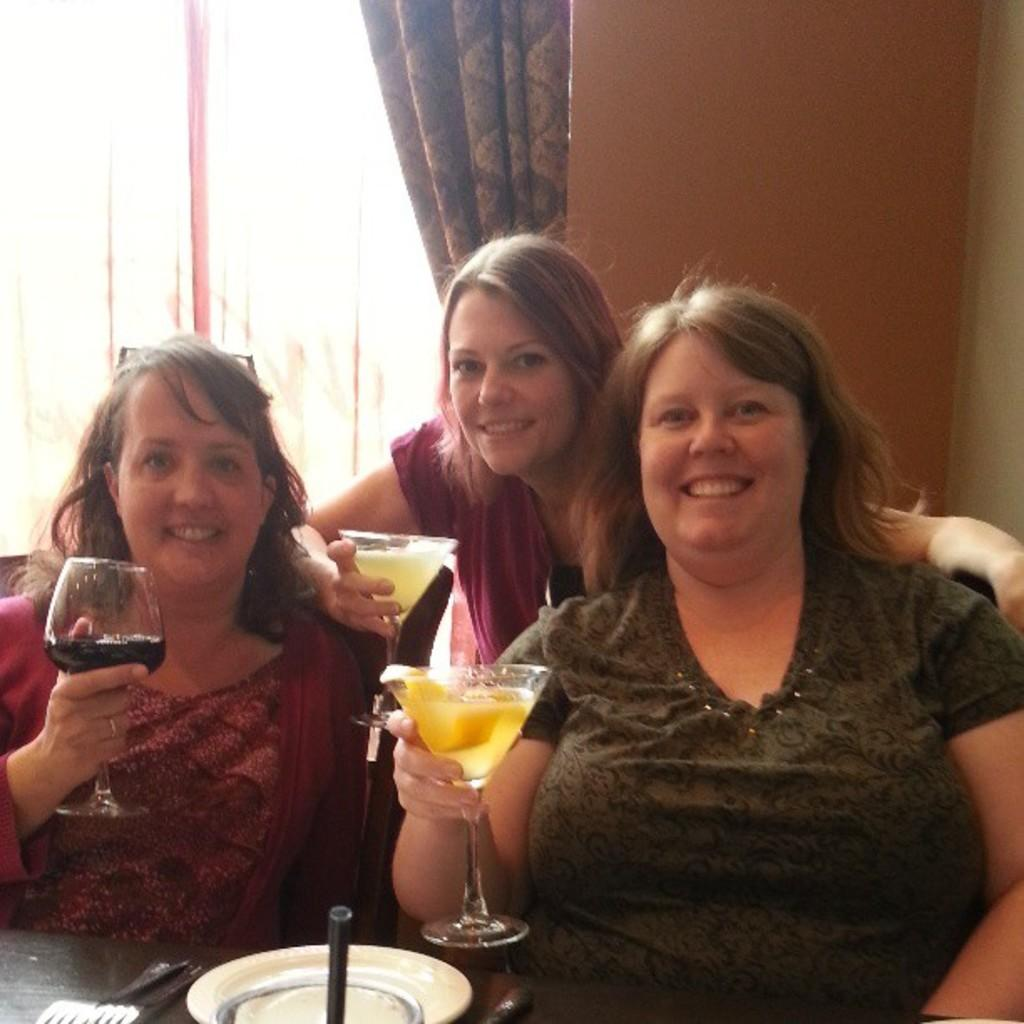What type of structure can be seen in the image? There is a wall in the image. What architectural feature is present in the wall? There is a window in the wall. What type of window treatment is visible in the image? There is a curtain in the image. How many people are present in the image? There are three people in the image. What are the three people holding in their hands? The three people are holding glasses. Can you tell me how much money the field is worth in the image? There is no field present in the image, and therefore no monetary value can be assigned to it. How does the curtain touch the window in the image? The curtain does not touch the window in the image; it is hanging from a rod or rail. 